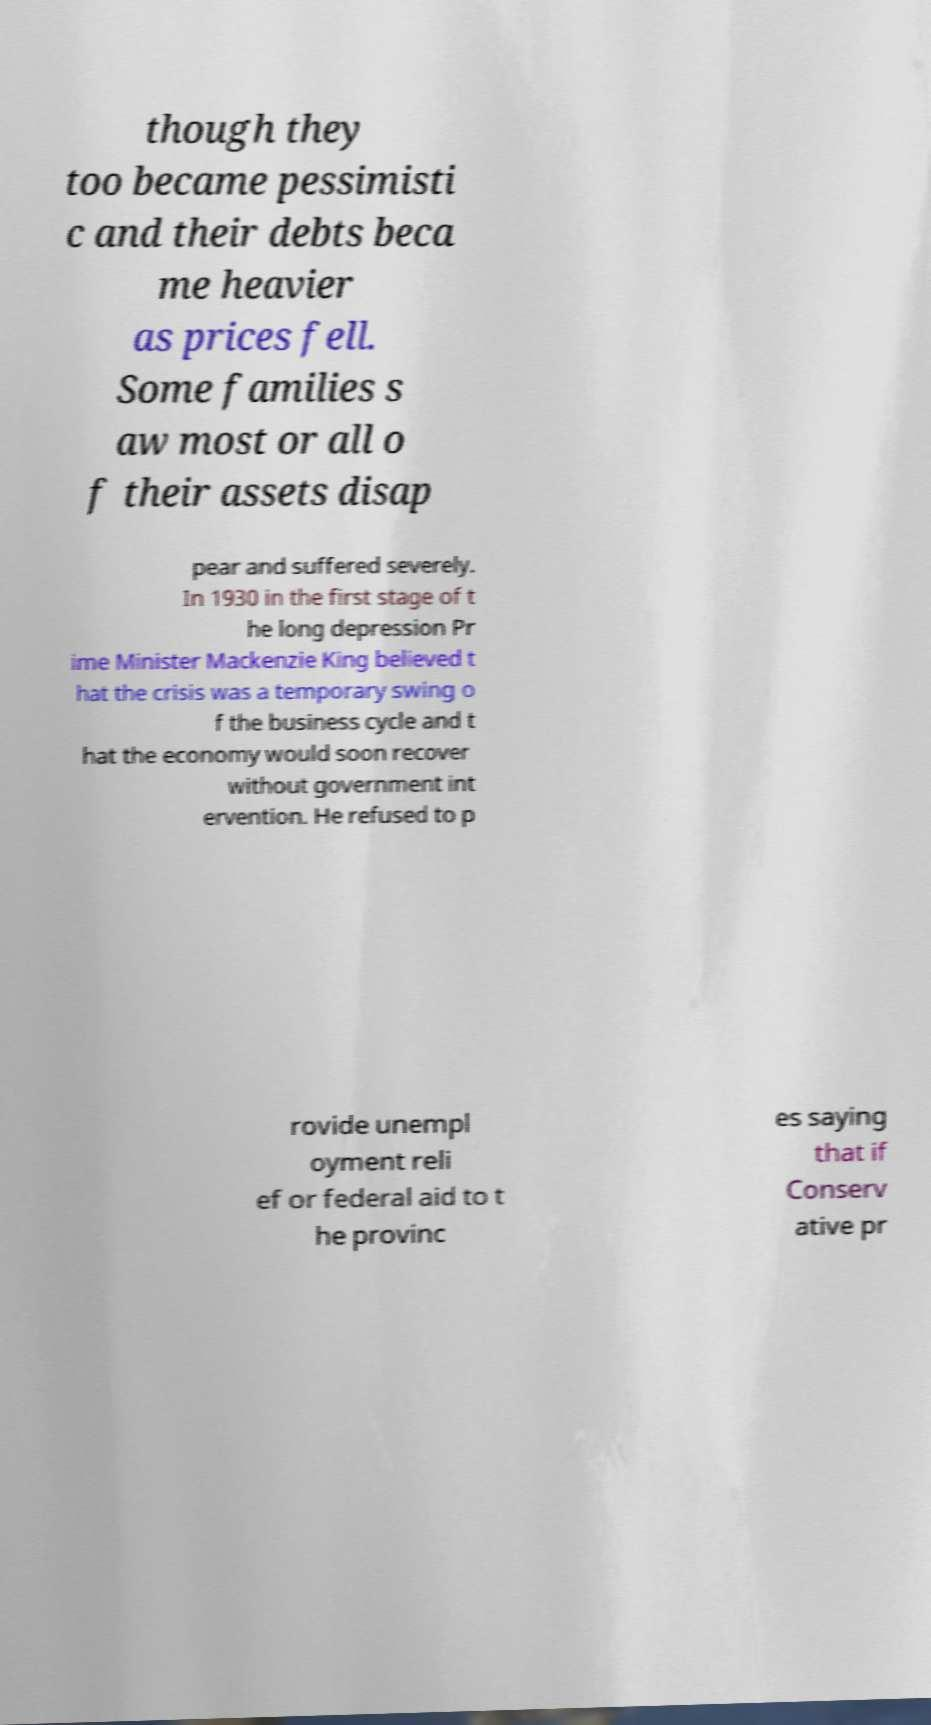What messages or text are displayed in this image? I need them in a readable, typed format. though they too became pessimisti c and their debts beca me heavier as prices fell. Some families s aw most or all o f their assets disap pear and suffered severely. In 1930 in the first stage of t he long depression Pr ime Minister Mackenzie King believed t hat the crisis was a temporary swing o f the business cycle and t hat the economy would soon recover without government int ervention. He refused to p rovide unempl oyment reli ef or federal aid to t he provinc es saying that if Conserv ative pr 